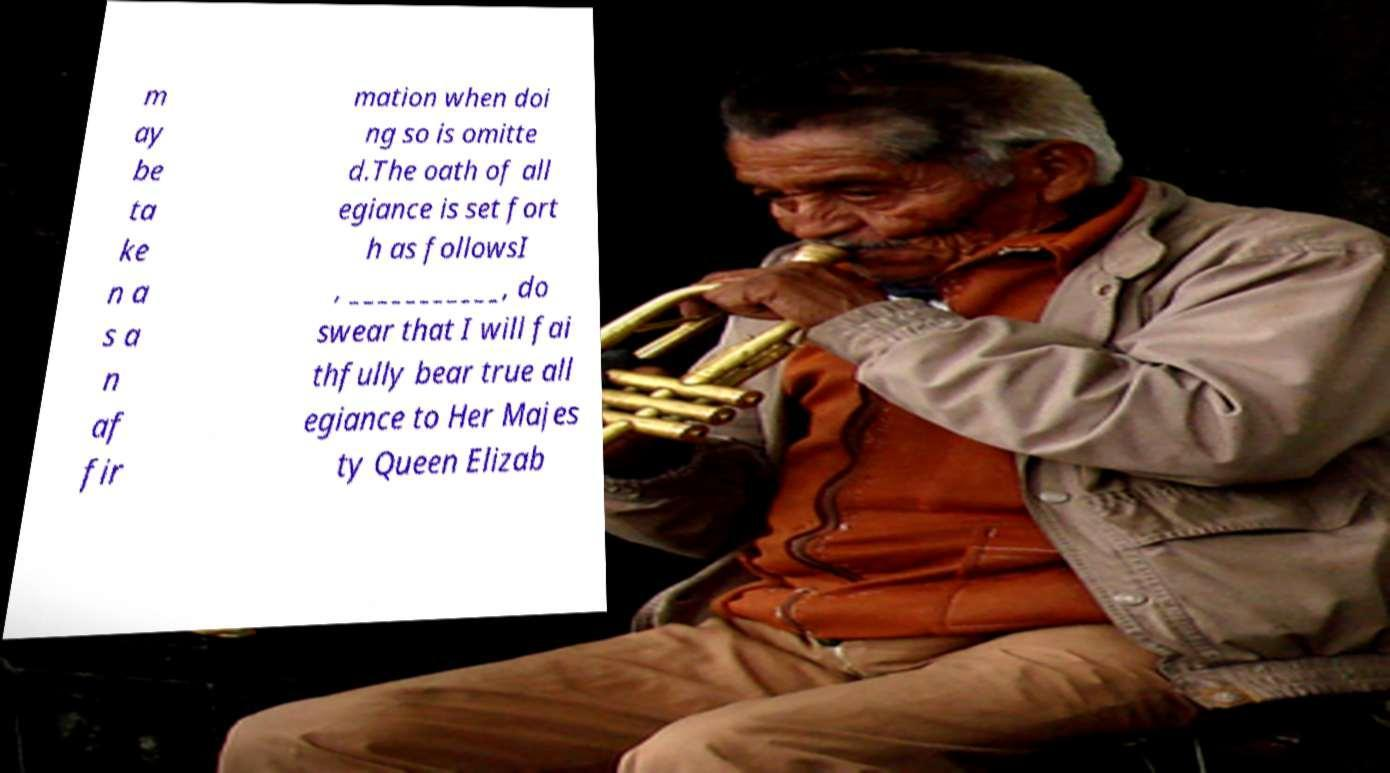Can you read and provide the text displayed in the image?This photo seems to have some interesting text. Can you extract and type it out for me? m ay be ta ke n a s a n af fir mation when doi ng so is omitte d.The oath of all egiance is set fort h as followsI , ___________, do swear that I will fai thfully bear true all egiance to Her Majes ty Queen Elizab 